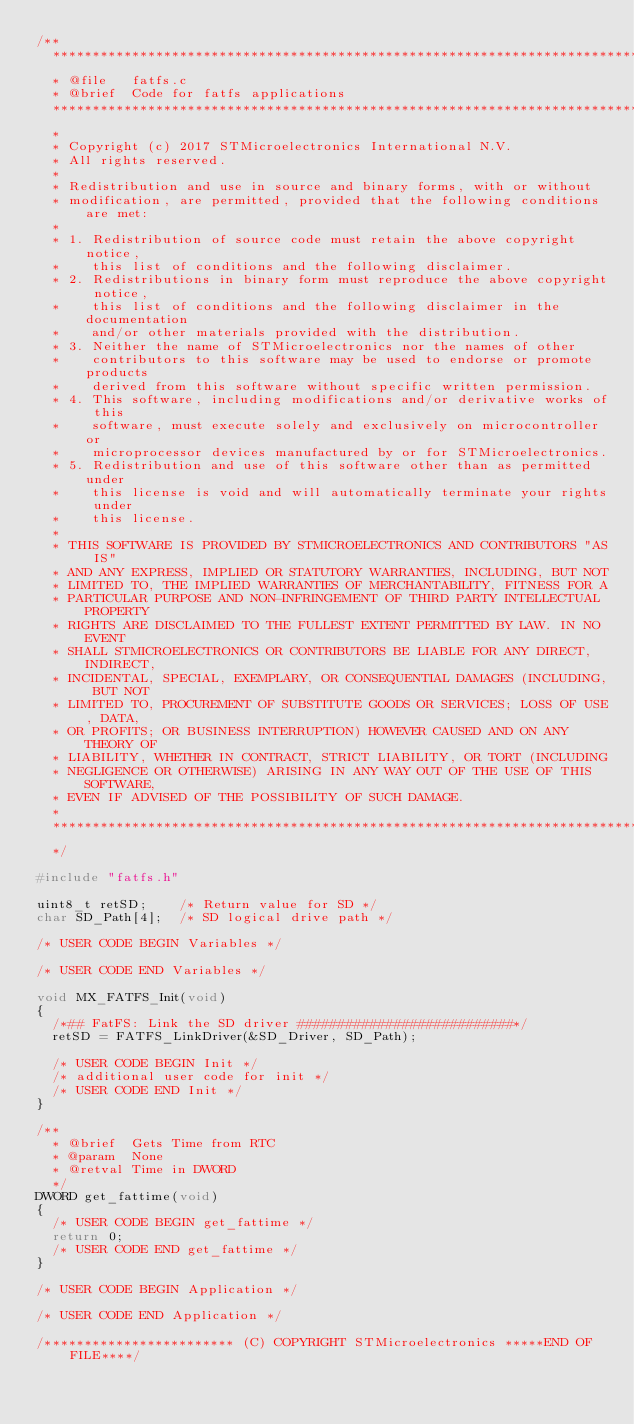Convert code to text. <code><loc_0><loc_0><loc_500><loc_500><_C_>/**
  ******************************************************************************
  * @file   fatfs.c
  * @brief  Code for fatfs applications
  ******************************************************************************
  *
  * Copyright (c) 2017 STMicroelectronics International N.V. 
  * All rights reserved.
  *
  * Redistribution and use in source and binary forms, with or without 
  * modification, are permitted, provided that the following conditions are met:
  *
  * 1. Redistribution of source code must retain the above copyright notice, 
  *    this list of conditions and the following disclaimer.
  * 2. Redistributions in binary form must reproduce the above copyright notice,
  *    this list of conditions and the following disclaimer in the documentation
  *    and/or other materials provided with the distribution.
  * 3. Neither the name of STMicroelectronics nor the names of other 
  *    contributors to this software may be used to endorse or promote products 
  *    derived from this software without specific written permission.
  * 4. This software, including modifications and/or derivative works of this 
  *    software, must execute solely and exclusively on microcontroller or
  *    microprocessor devices manufactured by or for STMicroelectronics.
  * 5. Redistribution and use of this software other than as permitted under 
  *    this license is void and will automatically terminate your rights under 
  *    this license. 
  *
  * THIS SOFTWARE IS PROVIDED BY STMICROELECTRONICS AND CONTRIBUTORS "AS IS" 
  * AND ANY EXPRESS, IMPLIED OR STATUTORY WARRANTIES, INCLUDING, BUT NOT 
  * LIMITED TO, THE IMPLIED WARRANTIES OF MERCHANTABILITY, FITNESS FOR A 
  * PARTICULAR PURPOSE AND NON-INFRINGEMENT OF THIRD PARTY INTELLECTUAL PROPERTY
  * RIGHTS ARE DISCLAIMED TO THE FULLEST EXTENT PERMITTED BY LAW. IN NO EVENT 
  * SHALL STMICROELECTRONICS OR CONTRIBUTORS BE LIABLE FOR ANY DIRECT, INDIRECT,
  * INCIDENTAL, SPECIAL, EXEMPLARY, OR CONSEQUENTIAL DAMAGES (INCLUDING, BUT NOT
  * LIMITED TO, PROCUREMENT OF SUBSTITUTE GOODS OR SERVICES; LOSS OF USE, DATA, 
  * OR PROFITS; OR BUSINESS INTERRUPTION) HOWEVER CAUSED AND ON ANY THEORY OF 
  * LIABILITY, WHETHER IN CONTRACT, STRICT LIABILITY, OR TORT (INCLUDING 
  * NEGLIGENCE OR OTHERWISE) ARISING IN ANY WAY OUT OF THE USE OF THIS SOFTWARE,
  * EVEN IF ADVISED OF THE POSSIBILITY OF SUCH DAMAGE.
  *
  ******************************************************************************
  */

#include "fatfs.h"

uint8_t retSD;    /* Return value for SD */
char SD_Path[4];  /* SD logical drive path */

/* USER CODE BEGIN Variables */

/* USER CODE END Variables */    

void MX_FATFS_Init(void) 
{
  /*## FatFS: Link the SD driver ###########################*/
  retSD = FATFS_LinkDriver(&SD_Driver, SD_Path);

  /* USER CODE BEGIN Init */
  /* additional user code for init */     
  /* USER CODE END Init */
}

/**
  * @brief  Gets Time from RTC 
  * @param  None
  * @retval Time in DWORD
  */
DWORD get_fattime(void)
{
  /* USER CODE BEGIN get_fattime */
  return 0;
  /* USER CODE END get_fattime */  
}

/* USER CODE BEGIN Application */
     
/* USER CODE END Application */

/************************ (C) COPYRIGHT STMicroelectronics *****END OF FILE****/
</code> 